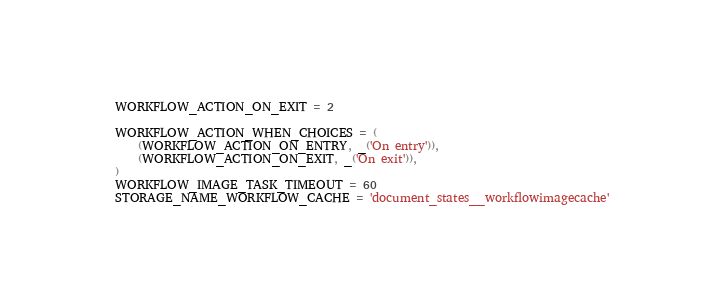<code> <loc_0><loc_0><loc_500><loc_500><_Python_>WORKFLOW_ACTION_ON_EXIT = 2

WORKFLOW_ACTION_WHEN_CHOICES = (
    (WORKFLOW_ACTION_ON_ENTRY, _('On entry')),
    (WORKFLOW_ACTION_ON_EXIT, _('On exit')),
)
WORKFLOW_IMAGE_TASK_TIMEOUT = 60
STORAGE_NAME_WORKFLOW_CACHE = 'document_states__workflowimagecache'
</code> 